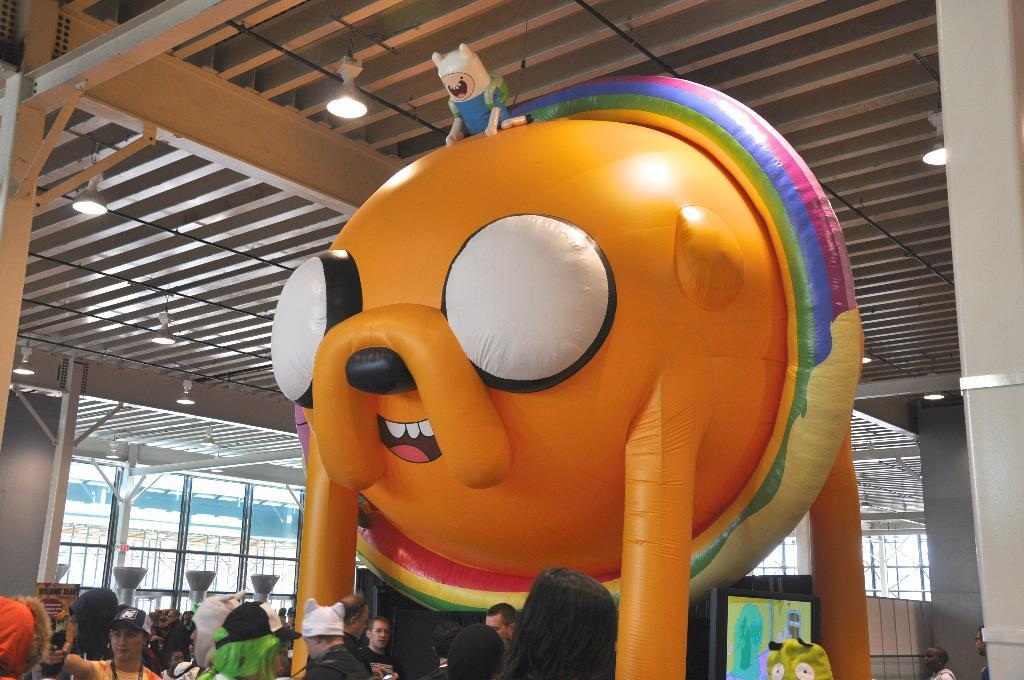What objects can be seen in the image? There are toys in the image. What are the people in the image doing? The people are standing on a path in the image. What can be seen illuminating the scene in the image? There are lights visible in the image. What is the size of the grain in the image? There is no grain present in the image, so it is not possible to determine its size. What type of doctor can be seen treating the toys in the image? There are no doctors or toy treatments depicted in the image. 